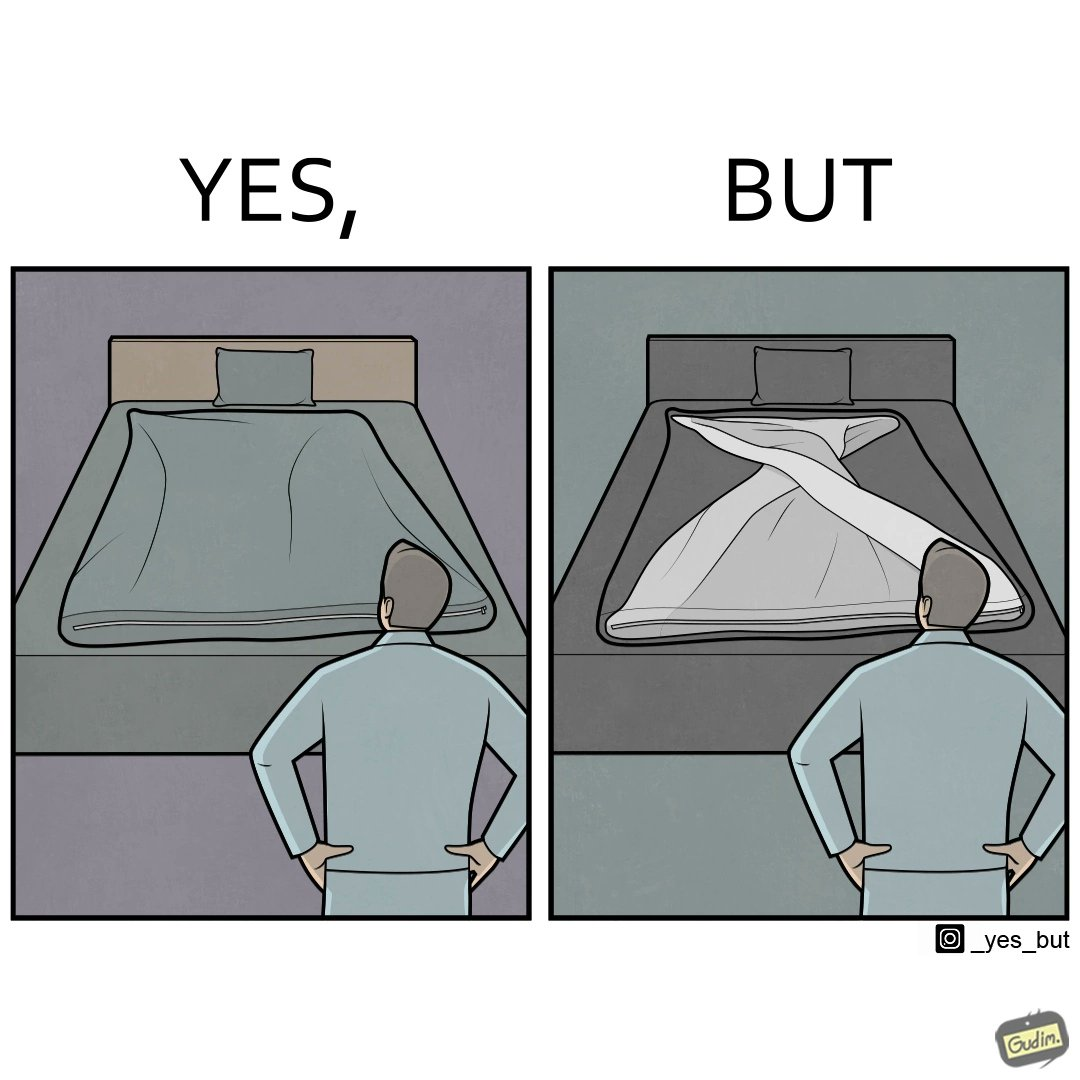Provide a description of this image. The image is funny because while the bed seems to be well made with the blanket on top, the actual blanket inside the blanket cover is twisted and not properly set. 